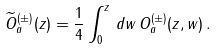<formula> <loc_0><loc_0><loc_500><loc_500>\widetilde { O } ^ { ( \pm ) } _ { a } ( z ) = \frac { 1 } { 4 } \int _ { 0 } ^ { z } \, d w \, { O } ^ { ( \pm ) } _ { a } ( z , w ) \, .</formula> 